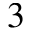Convert formula to latex. <formula><loc_0><loc_0><loc_500><loc_500>^ { 3 }</formula> 